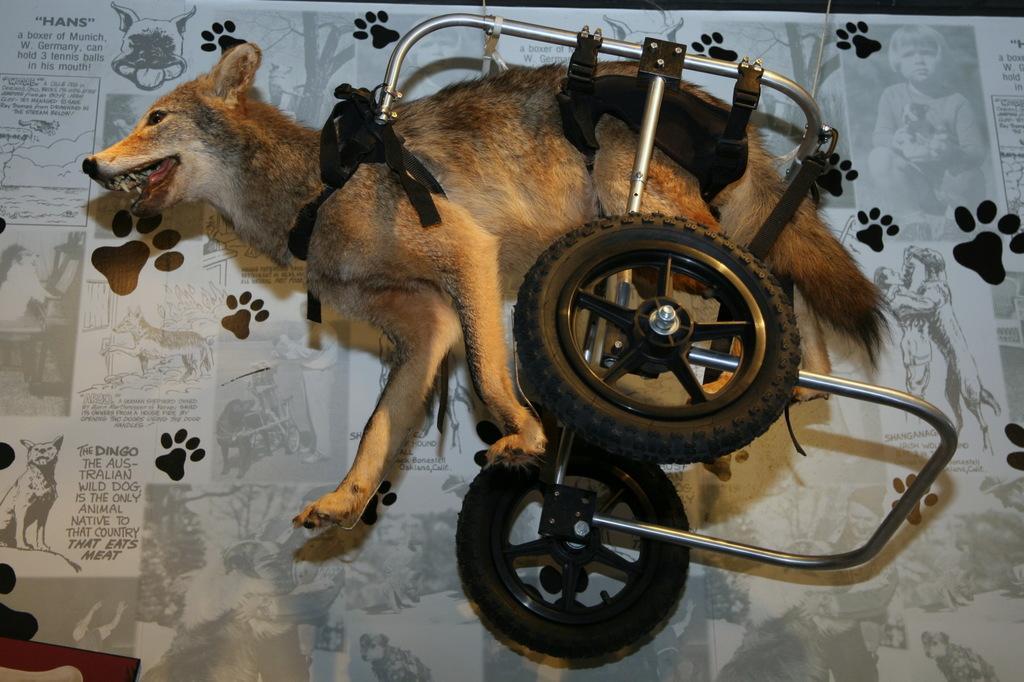Describe this image in one or two sentences. In this image I can see an animal which is brown, black and cream in color is tied to the vehicle. I can see the white and black colored background in which I can see few pictures of animals and persons. 